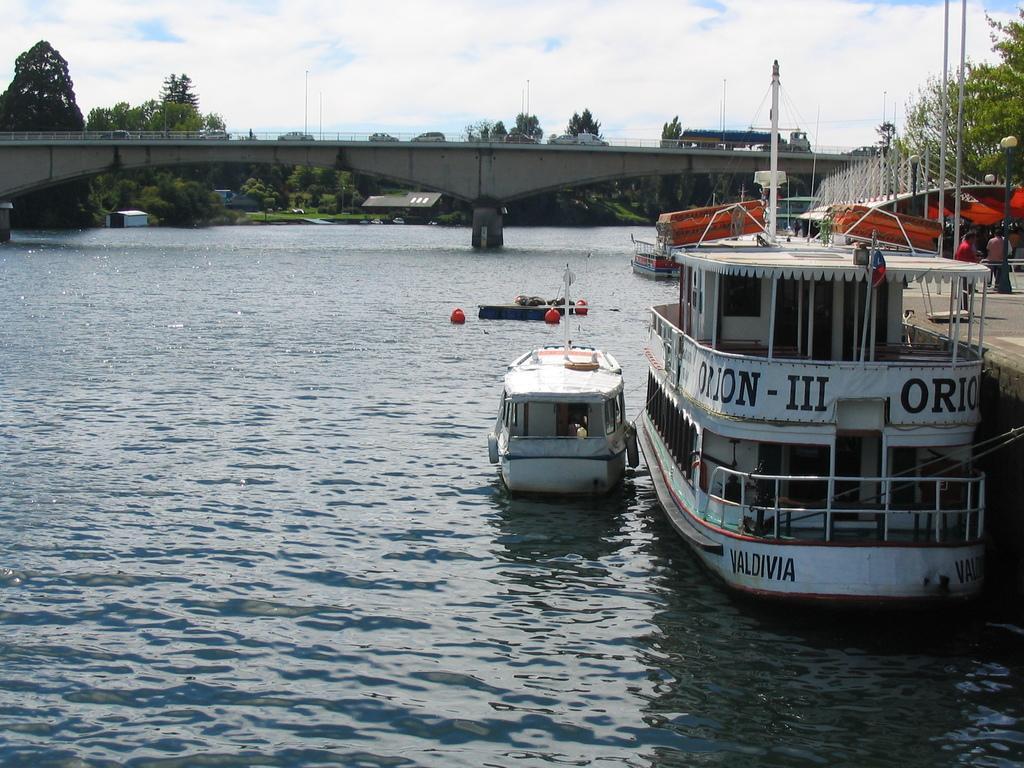Describe this image in one or two sentences. In this picture there are ships on the right side of the image, on the water and there is a bridge at the top side of the image, there is a dock on the right side of the image and there are trees in the background area of the image. 